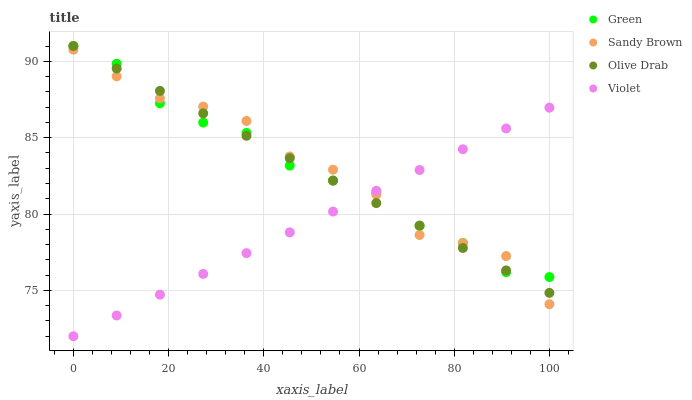Does Violet have the minimum area under the curve?
Answer yes or no. Yes. Does Sandy Brown have the maximum area under the curve?
Answer yes or no. Yes. Does Green have the minimum area under the curve?
Answer yes or no. No. Does Green have the maximum area under the curve?
Answer yes or no. No. Is Olive Drab the smoothest?
Answer yes or no. Yes. Is Sandy Brown the roughest?
Answer yes or no. Yes. Is Green the smoothest?
Answer yes or no. No. Is Green the roughest?
Answer yes or no. No. Does Violet have the lowest value?
Answer yes or no. Yes. Does Olive Drab have the lowest value?
Answer yes or no. No. Does Olive Drab have the highest value?
Answer yes or no. Yes. Does Violet have the highest value?
Answer yes or no. No. Does Olive Drab intersect Violet?
Answer yes or no. Yes. Is Olive Drab less than Violet?
Answer yes or no. No. Is Olive Drab greater than Violet?
Answer yes or no. No. 